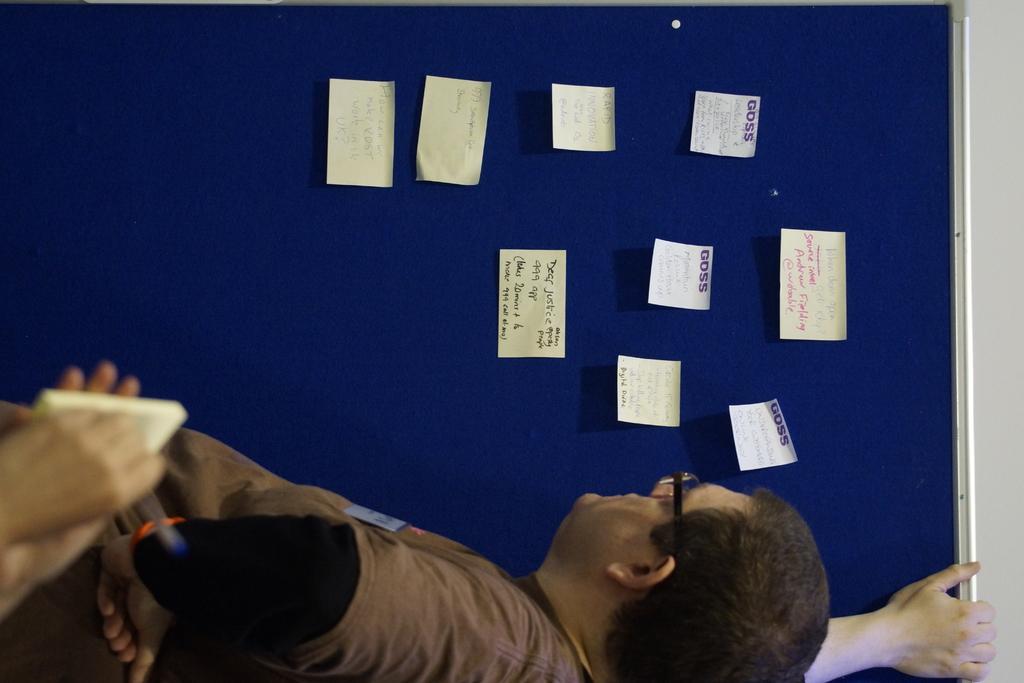Describe this image in one or two sentences. This picture is in leftward direction. On the top, there is a notice board with papers. At the bottom, there is a person wearing a brown t shirt and holding a board. Towards the left, there is another person. 